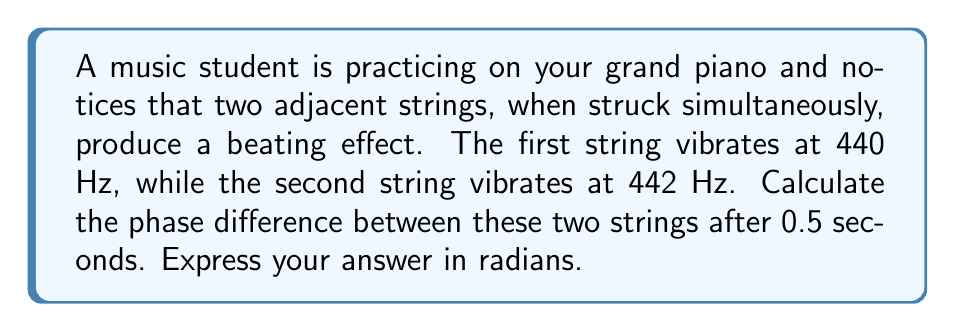Can you answer this question? To solve this problem, we need to follow these steps:

1) First, let's understand what causes the phase difference. The two strings are vibrating at slightly different frequencies, which means they complete their cycles at different rates.

2) We can represent the displacement of each string as a sine function:
   String 1: $y_1 = \sin(2\pi f_1 t)$
   String 2: $y_2 = \sin(2\pi f_2 t)$
   Where $f_1 = 440$ Hz and $f_2 = 442$ Hz

3) The phase difference $\phi$ at time $t$ is given by:
   $$\phi = 2\pi(f_2 - f_1)t$$

4) Let's substitute our values:
   $$\phi = 2\pi(442 - 440)(0.5)$$

5) Simplify:
   $$\phi = 2\pi(2)(0.5) = 2\pi$$

6) Therefore, after 0.5 seconds, the phase difference is $2\pi$ radians.

Note: A phase difference of $2\pi$ radians is equivalent to a full cycle, meaning the strings have come back into phase after being out of phase for a complete cycle.
Answer: $2\pi$ radians 